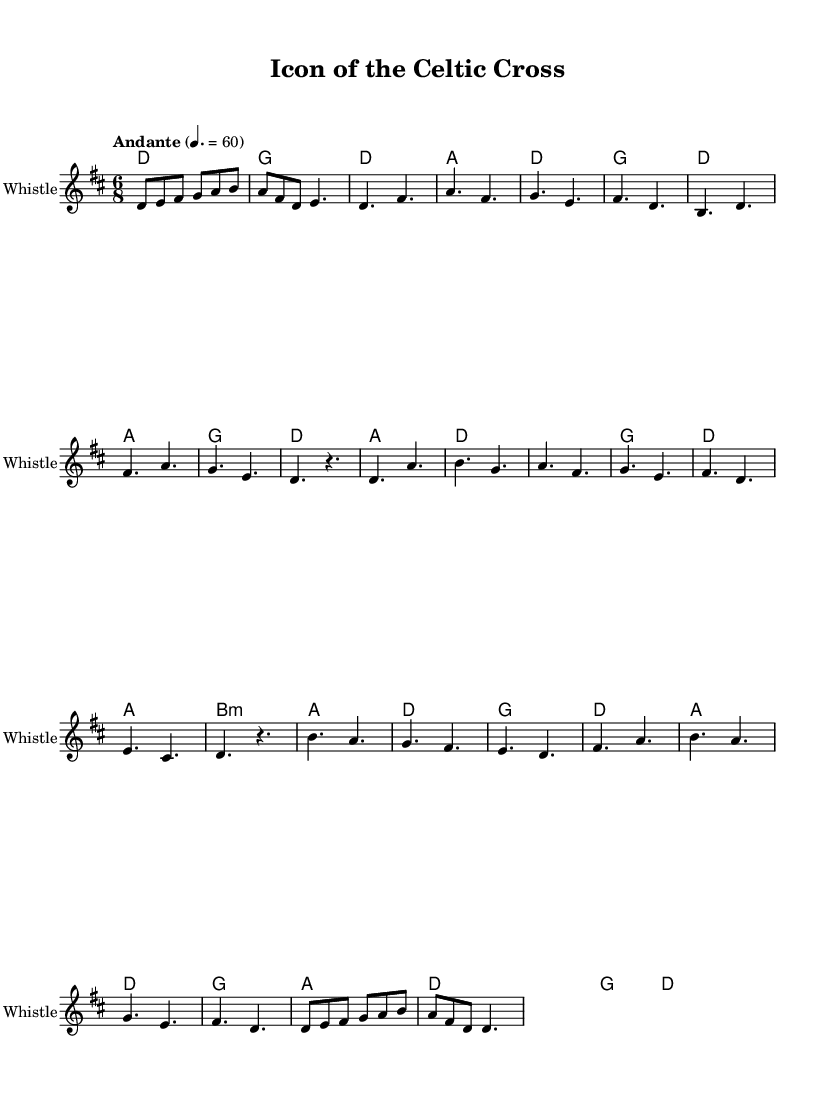What is the key signature of this music? The key signature is D major, indicated by two sharps (F# and C#) at the beginning of the staff.
Answer: D major What is the time signature of this piece? The time signature is 6/8, which indicates a compound duple meter with six eighth notes per measure, allowing for a flowing and lilting rhythm typical of folk music.
Answer: 6/8 What is the tempo marking given in the score? The tempo marking is "Andante," which suggests a moderate walking pace. In the context of the music, it allows for expressive phrasing, aligning well with folk traditions.
Answer: Andante How many measures are in the verse section of the music? The verse section consists of eight measures, as can be counted from the grouping of musical phrases defined in the score.
Answer: Eight measures What instrument is designated for the melody in the score? The melody is designated for the "Irish Whistle," which is common in Celtic folk music for its bright and airy sound that complements the spiritual themes of ancient imagery.
Answer: Irish Whistle Identify one chord used in the chorus section. One chord used in the chorus section is A major, which can be found in the harmonic progression accompanying the melody. It contributes to the brightness characteristic of folk music.
Answer: A major Which part of the music contains a bridge? The bridge is located after the chorus; it serves as a contrasting section that transitions back to the melodies established earlier, providing variety and maintaining interest in the structure of the piece.
Answer: Bridge 